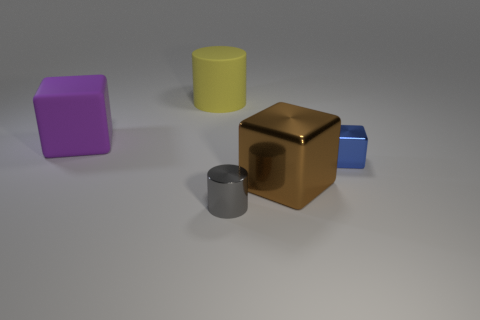Add 1 purple rubber blocks. How many objects exist? 6 Subtract all cylinders. How many objects are left? 3 Subtract 0 brown cylinders. How many objects are left? 5 Subtract all yellow cylinders. Subtract all brown blocks. How many objects are left? 3 Add 3 metallic cubes. How many metallic cubes are left? 5 Add 2 green metallic spheres. How many green metallic spheres exist? 2 